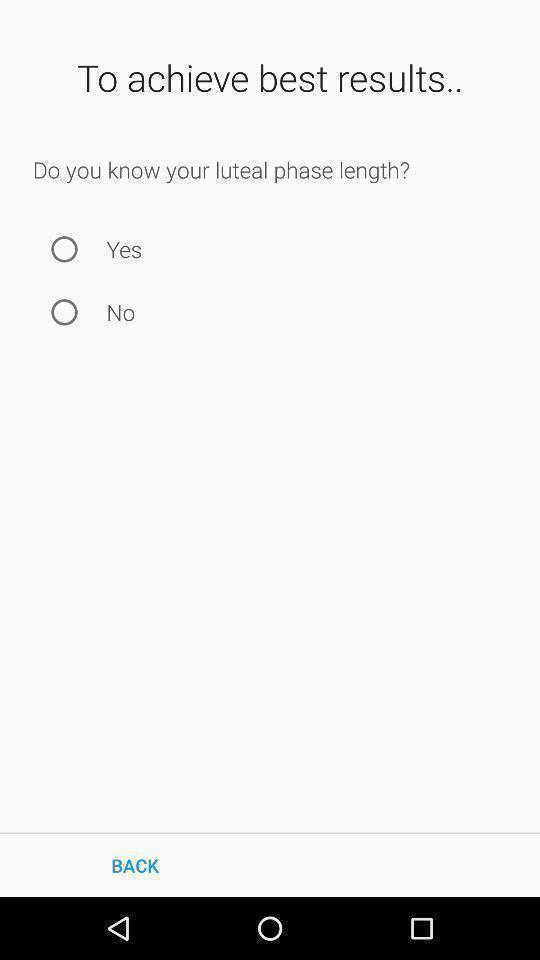What is the overall content of this screenshot? Page displaying two options to select. 